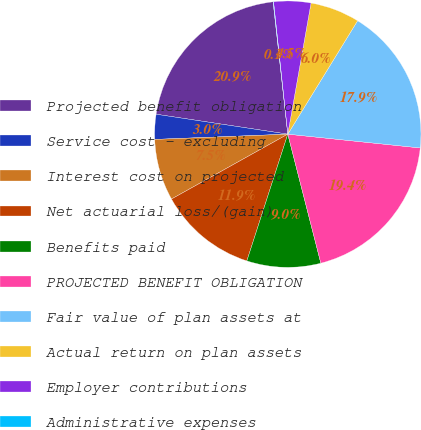<chart> <loc_0><loc_0><loc_500><loc_500><pie_chart><fcel>Projected benefit obligation<fcel>Service cost - excluding<fcel>Interest cost on projected<fcel>Net actuarial loss/(gain)<fcel>Benefits paid<fcel>PROJECTED BENEFIT OBLIGATION<fcel>Fair value of plan assets at<fcel>Actual return on plan assets<fcel>Employer contributions<fcel>Administrative expenses<nl><fcel>20.85%<fcel>3.02%<fcel>7.47%<fcel>11.93%<fcel>8.96%<fcel>19.36%<fcel>17.87%<fcel>5.99%<fcel>4.5%<fcel>0.05%<nl></chart> 